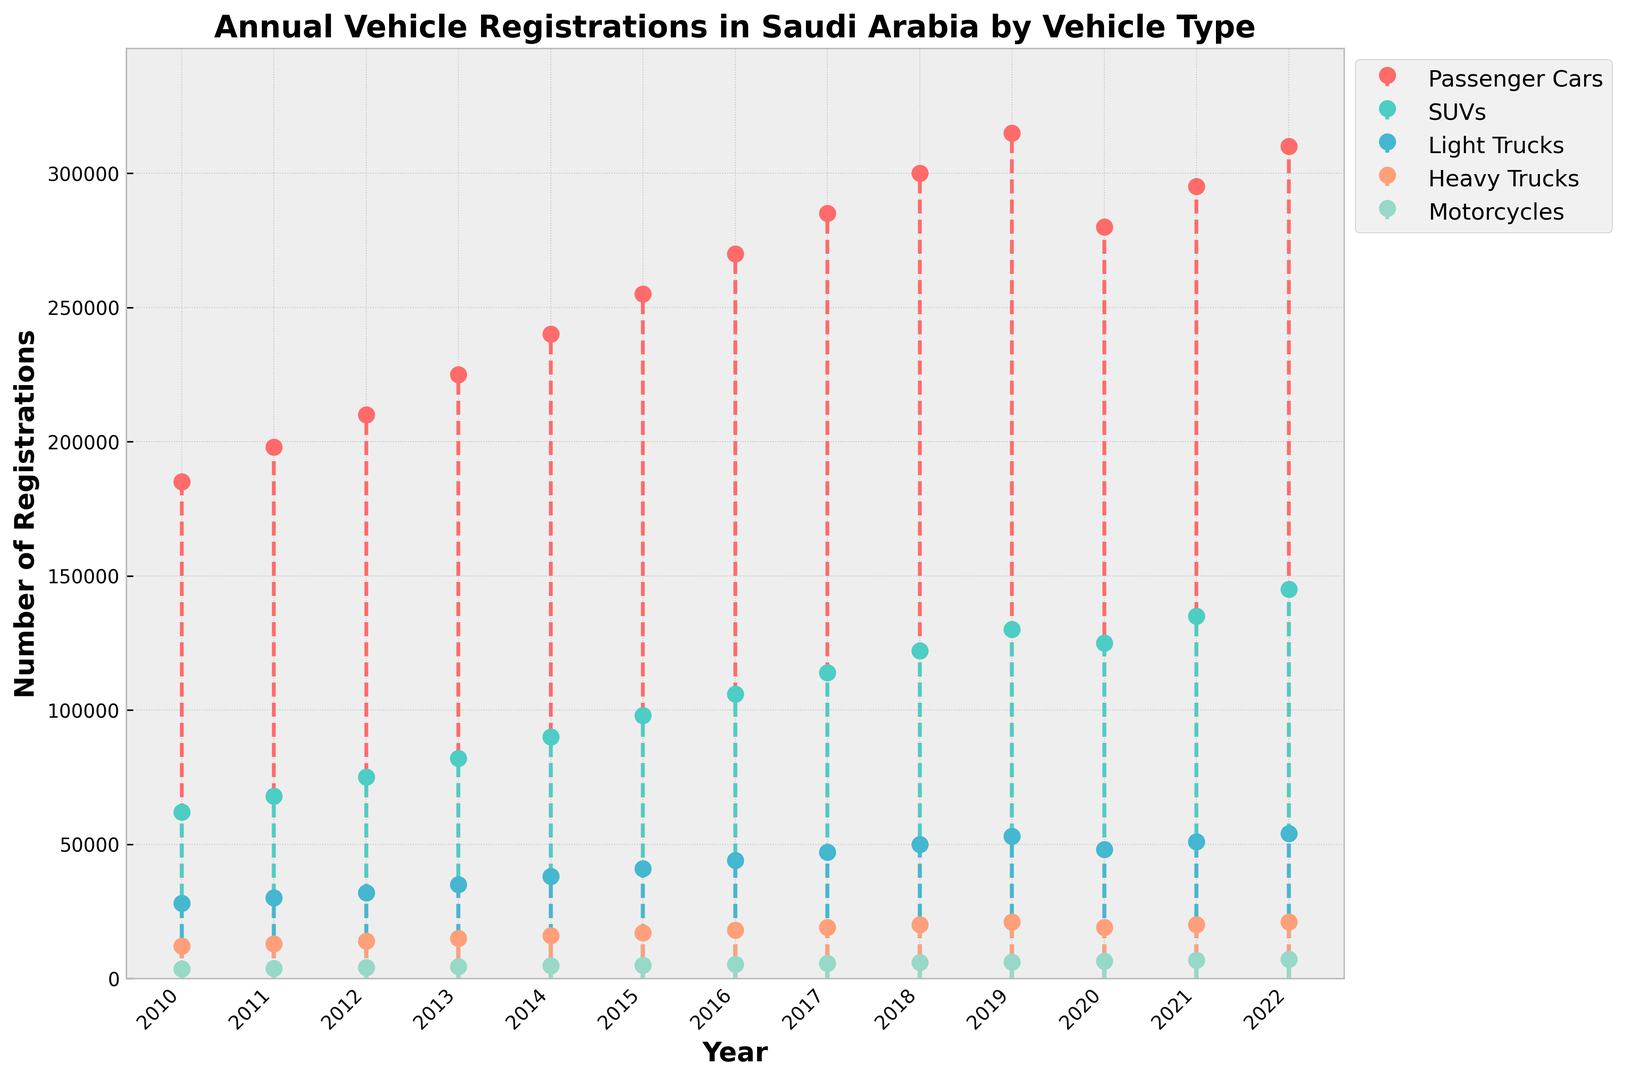What vehicle type had the highest number of registrations in 2022? The figure shows stem lines of different colors representing various vehicle types. The highest point in 2022 corresponds to Passenger Cars with 310,000 registrations.
Answer: Passenger Cars Which vehicle type shows a decrease in the number of registrations from 2019 to 2020? By comparing the heights of the stem lines for 2019 and 2020, we see that Passenger Cars and SUVs have decreased from 315,000 to 280,000, and from 130,000 to 125,000 respectively.
Answer: Passenger Cars, SUVs What was the total number of vehicle registrations for all types in 2015? Add the number of registrations for each vehicle type in 2015: Passenger Cars (255,000), SUVs (98,000), Light Trucks (41,000), Heavy Trucks (17,000), and Motorcycles (5,000). The sum is 255,000 + 98,000 + 41,000 + 17,000 + 5,000 = 416,000.
Answer: 416,000 How did the registrations for SUVs change from 2010 to 2016? Determine the difference in SUV registrations between 2010 (62,000) and 2016 (106,000): 106,000 - 62,000 = 44,000. This shows an increase.
Answer: Increased by 44,000 What was the average number of Motorcycle registrations between 2010 and 2013? Calculate the average by adding motorcycle registrations from 2010 to 2013: (3,500 + 3,800 + 4,100 + 4,400) = 15,800, then divide by 4: 15,800 / 4 = 3,950.
Answer: 3,950 Which vehicle type shows a consistent upward trend from 2010 to 2022? By visually inspecting each vehicle type's stem lines from 2010 to 2022, we see that SUV registrations consistently increase every year.
Answer: SUVs In which year did Passenger Cars see the largest increase in registrations compared to the previous year? Checking the yearly differences for Passenger Cars: 
2011: 198,000 - 185,000 = 13,000
2012: 210,000 - 198,000 = 12,000
2013: 225,000 - 210,000 = 15,000
2014: 240,000 - 225,000 = 15,000
2015: 255,000 - 240,000 = 15,000
2016: 270,000 - 255,000 = 15,000
2017: 285,000 - 270,000 = 15,000
2018: 300,000 - 285,000 = 15,000
2019: 315,000 - 300,000 = 15,000
Largest increase is in 2013, 2014, 2015, 2016, 2017, 2018, 2019, which are all equal but highest increments.
Answer: 2013-2019 What is the difference in the number of registrations for Light Trucks between 2018 and 2021? Subtract the number of registrations for Light Trucks in 2018 (50,000) from 2021 (51,000): 51,000 - 50,000 = 1,000.
Answer: 1,000 Which vehicle type had the smallest number of registrations in 2022? By observing the endpoint of each stem line for 2022, Motorcycles have the lowest number of registrations with 7,100.
Answer: Motorcycles 